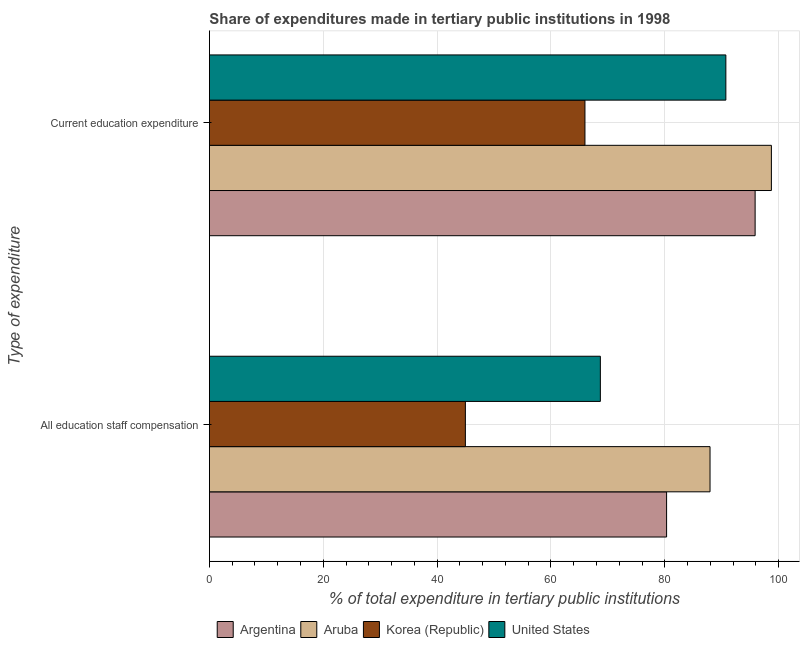How many different coloured bars are there?
Make the answer very short. 4. How many groups of bars are there?
Offer a terse response. 2. Are the number of bars on each tick of the Y-axis equal?
Provide a short and direct response. Yes. What is the label of the 2nd group of bars from the top?
Ensure brevity in your answer.  All education staff compensation. What is the expenditure in staff compensation in United States?
Provide a short and direct response. 68.68. Across all countries, what is the maximum expenditure in education?
Provide a short and direct response. 98.73. Across all countries, what is the minimum expenditure in staff compensation?
Provide a short and direct response. 44.97. In which country was the expenditure in education maximum?
Offer a very short reply. Aruba. What is the total expenditure in education in the graph?
Provide a short and direct response. 351.29. What is the difference between the expenditure in education in Argentina and that in United States?
Make the answer very short. 5.14. What is the difference between the expenditure in education in Argentina and the expenditure in staff compensation in Aruba?
Keep it short and to the point. 7.92. What is the average expenditure in staff compensation per country?
Your response must be concise. 70.48. What is the difference between the expenditure in education and expenditure in staff compensation in Aruba?
Your answer should be compact. 10.78. What is the ratio of the expenditure in staff compensation in Aruba to that in Korea (Republic)?
Offer a terse response. 1.96. In how many countries, is the expenditure in staff compensation greater than the average expenditure in staff compensation taken over all countries?
Provide a short and direct response. 2. What does the 4th bar from the top in Current education expenditure represents?
Give a very brief answer. Argentina. What does the 2nd bar from the bottom in All education staff compensation represents?
Give a very brief answer. Aruba. Are all the bars in the graph horizontal?
Provide a short and direct response. Yes. How many countries are there in the graph?
Provide a succinct answer. 4. Where does the legend appear in the graph?
Make the answer very short. Bottom center. How many legend labels are there?
Make the answer very short. 4. How are the legend labels stacked?
Make the answer very short. Horizontal. What is the title of the graph?
Make the answer very short. Share of expenditures made in tertiary public institutions in 1998. Does "Korea (Democratic)" appear as one of the legend labels in the graph?
Offer a terse response. No. What is the label or title of the X-axis?
Offer a very short reply. % of total expenditure in tertiary public institutions. What is the label or title of the Y-axis?
Offer a very short reply. Type of expenditure. What is the % of total expenditure in tertiary public institutions of Argentina in All education staff compensation?
Your answer should be very brief. 80.32. What is the % of total expenditure in tertiary public institutions of Aruba in All education staff compensation?
Ensure brevity in your answer.  87.95. What is the % of total expenditure in tertiary public institutions of Korea (Republic) in All education staff compensation?
Keep it short and to the point. 44.97. What is the % of total expenditure in tertiary public institutions in United States in All education staff compensation?
Offer a terse response. 68.68. What is the % of total expenditure in tertiary public institutions in Argentina in Current education expenditure?
Ensure brevity in your answer.  95.87. What is the % of total expenditure in tertiary public institutions in Aruba in Current education expenditure?
Provide a succinct answer. 98.73. What is the % of total expenditure in tertiary public institutions of Korea (Republic) in Current education expenditure?
Make the answer very short. 65.97. What is the % of total expenditure in tertiary public institutions in United States in Current education expenditure?
Offer a very short reply. 90.73. Across all Type of expenditure, what is the maximum % of total expenditure in tertiary public institutions of Argentina?
Your response must be concise. 95.87. Across all Type of expenditure, what is the maximum % of total expenditure in tertiary public institutions of Aruba?
Give a very brief answer. 98.73. Across all Type of expenditure, what is the maximum % of total expenditure in tertiary public institutions of Korea (Republic)?
Give a very brief answer. 65.97. Across all Type of expenditure, what is the maximum % of total expenditure in tertiary public institutions in United States?
Offer a terse response. 90.73. Across all Type of expenditure, what is the minimum % of total expenditure in tertiary public institutions of Argentina?
Provide a short and direct response. 80.32. Across all Type of expenditure, what is the minimum % of total expenditure in tertiary public institutions of Aruba?
Give a very brief answer. 87.95. Across all Type of expenditure, what is the minimum % of total expenditure in tertiary public institutions of Korea (Republic)?
Provide a succinct answer. 44.97. Across all Type of expenditure, what is the minimum % of total expenditure in tertiary public institutions of United States?
Provide a succinct answer. 68.68. What is the total % of total expenditure in tertiary public institutions of Argentina in the graph?
Your answer should be very brief. 176.18. What is the total % of total expenditure in tertiary public institutions in Aruba in the graph?
Keep it short and to the point. 186.67. What is the total % of total expenditure in tertiary public institutions in Korea (Republic) in the graph?
Your answer should be compact. 110.94. What is the total % of total expenditure in tertiary public institutions of United States in the graph?
Keep it short and to the point. 159.41. What is the difference between the % of total expenditure in tertiary public institutions in Argentina in All education staff compensation and that in Current education expenditure?
Your answer should be very brief. -15.55. What is the difference between the % of total expenditure in tertiary public institutions of Aruba in All education staff compensation and that in Current education expenditure?
Your answer should be very brief. -10.78. What is the difference between the % of total expenditure in tertiary public institutions of Korea (Republic) in All education staff compensation and that in Current education expenditure?
Ensure brevity in your answer.  -21.01. What is the difference between the % of total expenditure in tertiary public institutions of United States in All education staff compensation and that in Current education expenditure?
Ensure brevity in your answer.  -22.05. What is the difference between the % of total expenditure in tertiary public institutions of Argentina in All education staff compensation and the % of total expenditure in tertiary public institutions of Aruba in Current education expenditure?
Your answer should be very brief. -18.41. What is the difference between the % of total expenditure in tertiary public institutions of Argentina in All education staff compensation and the % of total expenditure in tertiary public institutions of Korea (Republic) in Current education expenditure?
Keep it short and to the point. 14.34. What is the difference between the % of total expenditure in tertiary public institutions in Argentina in All education staff compensation and the % of total expenditure in tertiary public institutions in United States in Current education expenditure?
Ensure brevity in your answer.  -10.41. What is the difference between the % of total expenditure in tertiary public institutions of Aruba in All education staff compensation and the % of total expenditure in tertiary public institutions of Korea (Republic) in Current education expenditure?
Provide a succinct answer. 21.97. What is the difference between the % of total expenditure in tertiary public institutions in Aruba in All education staff compensation and the % of total expenditure in tertiary public institutions in United States in Current education expenditure?
Offer a terse response. -2.78. What is the difference between the % of total expenditure in tertiary public institutions in Korea (Republic) in All education staff compensation and the % of total expenditure in tertiary public institutions in United States in Current education expenditure?
Your answer should be compact. -45.76. What is the average % of total expenditure in tertiary public institutions in Argentina per Type of expenditure?
Provide a short and direct response. 88.09. What is the average % of total expenditure in tertiary public institutions of Aruba per Type of expenditure?
Keep it short and to the point. 93.34. What is the average % of total expenditure in tertiary public institutions of Korea (Republic) per Type of expenditure?
Your answer should be very brief. 55.47. What is the average % of total expenditure in tertiary public institutions of United States per Type of expenditure?
Make the answer very short. 79.7. What is the difference between the % of total expenditure in tertiary public institutions of Argentina and % of total expenditure in tertiary public institutions of Aruba in All education staff compensation?
Offer a terse response. -7.63. What is the difference between the % of total expenditure in tertiary public institutions of Argentina and % of total expenditure in tertiary public institutions of Korea (Republic) in All education staff compensation?
Your answer should be compact. 35.35. What is the difference between the % of total expenditure in tertiary public institutions in Argentina and % of total expenditure in tertiary public institutions in United States in All education staff compensation?
Provide a short and direct response. 11.64. What is the difference between the % of total expenditure in tertiary public institutions of Aruba and % of total expenditure in tertiary public institutions of Korea (Republic) in All education staff compensation?
Offer a terse response. 42.98. What is the difference between the % of total expenditure in tertiary public institutions in Aruba and % of total expenditure in tertiary public institutions in United States in All education staff compensation?
Provide a short and direct response. 19.27. What is the difference between the % of total expenditure in tertiary public institutions of Korea (Republic) and % of total expenditure in tertiary public institutions of United States in All education staff compensation?
Keep it short and to the point. -23.72. What is the difference between the % of total expenditure in tertiary public institutions in Argentina and % of total expenditure in tertiary public institutions in Aruba in Current education expenditure?
Provide a succinct answer. -2.86. What is the difference between the % of total expenditure in tertiary public institutions in Argentina and % of total expenditure in tertiary public institutions in Korea (Republic) in Current education expenditure?
Provide a short and direct response. 29.9. What is the difference between the % of total expenditure in tertiary public institutions in Argentina and % of total expenditure in tertiary public institutions in United States in Current education expenditure?
Give a very brief answer. 5.14. What is the difference between the % of total expenditure in tertiary public institutions in Aruba and % of total expenditure in tertiary public institutions in Korea (Republic) in Current education expenditure?
Give a very brief answer. 32.75. What is the difference between the % of total expenditure in tertiary public institutions in Aruba and % of total expenditure in tertiary public institutions in United States in Current education expenditure?
Your response must be concise. 8. What is the difference between the % of total expenditure in tertiary public institutions in Korea (Republic) and % of total expenditure in tertiary public institutions in United States in Current education expenditure?
Keep it short and to the point. -24.75. What is the ratio of the % of total expenditure in tertiary public institutions in Argentina in All education staff compensation to that in Current education expenditure?
Give a very brief answer. 0.84. What is the ratio of the % of total expenditure in tertiary public institutions of Aruba in All education staff compensation to that in Current education expenditure?
Your answer should be compact. 0.89. What is the ratio of the % of total expenditure in tertiary public institutions of Korea (Republic) in All education staff compensation to that in Current education expenditure?
Provide a succinct answer. 0.68. What is the ratio of the % of total expenditure in tertiary public institutions in United States in All education staff compensation to that in Current education expenditure?
Your response must be concise. 0.76. What is the difference between the highest and the second highest % of total expenditure in tertiary public institutions in Argentina?
Your answer should be compact. 15.55. What is the difference between the highest and the second highest % of total expenditure in tertiary public institutions of Aruba?
Give a very brief answer. 10.78. What is the difference between the highest and the second highest % of total expenditure in tertiary public institutions of Korea (Republic)?
Ensure brevity in your answer.  21.01. What is the difference between the highest and the second highest % of total expenditure in tertiary public institutions in United States?
Ensure brevity in your answer.  22.05. What is the difference between the highest and the lowest % of total expenditure in tertiary public institutions in Argentina?
Keep it short and to the point. 15.55. What is the difference between the highest and the lowest % of total expenditure in tertiary public institutions in Aruba?
Provide a succinct answer. 10.78. What is the difference between the highest and the lowest % of total expenditure in tertiary public institutions of Korea (Republic)?
Keep it short and to the point. 21.01. What is the difference between the highest and the lowest % of total expenditure in tertiary public institutions of United States?
Your answer should be very brief. 22.05. 